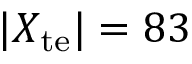Convert formula to latex. <formula><loc_0><loc_0><loc_500><loc_500>| X _ { t e } | = 8 3</formula> 